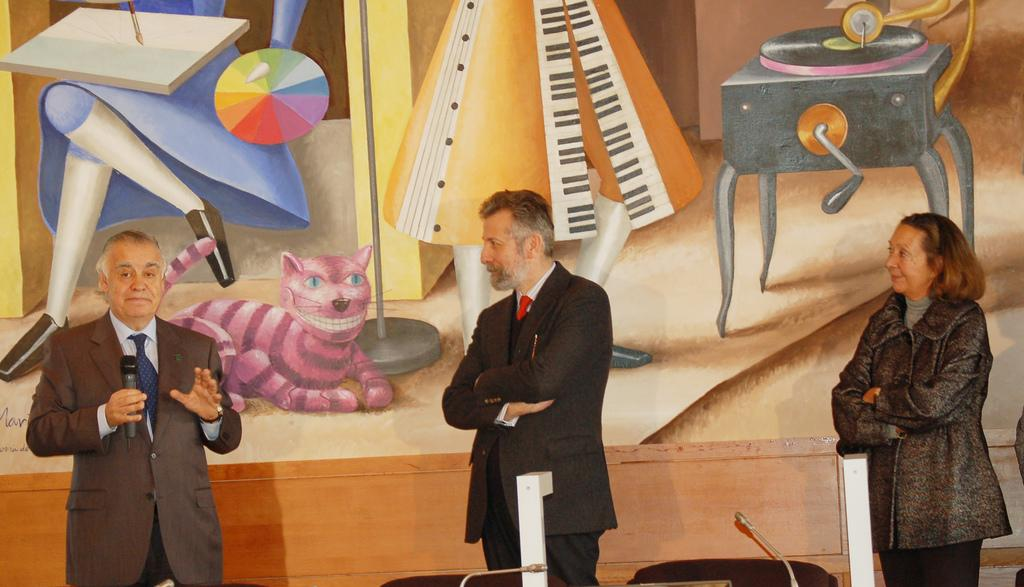How many people are present in the image? There are a few people in the image. What objects can be seen in the image that are used for amplifying sound? There are microphones in the image. What type of structures are visible in the image? There are poles in the image. What color can be observed in the image for some objects? There are black colored objects in the image. What can be seen in the background of the image? There is a wall with some painting in the background of the image. What type of beef is being served at the competition in the image? There is no beef or competition present in the image. What type of destruction can be seen in the image? There is no destruction present in the image. 